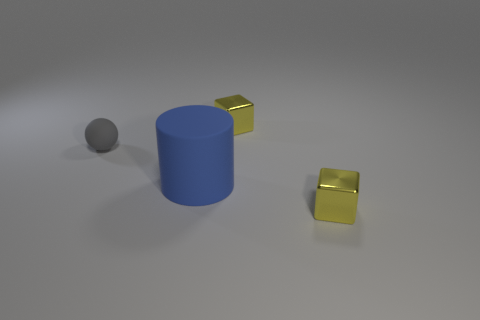What is the color of the tiny thing that is made of the same material as the big blue object?
Keep it short and to the point. Gray. What number of metal cubes are the same size as the gray matte thing?
Your answer should be compact. 2. Are there more matte objects than small objects?
Ensure brevity in your answer.  No. Does the small rubber object have the same shape as the big matte object?
Your response must be concise. No. Are there any other things that are the same shape as the large blue matte object?
Give a very brief answer. No. Do the shiny cube that is in front of the big matte cylinder and the metallic object that is behind the blue rubber thing have the same color?
Ensure brevity in your answer.  Yes. Is the number of small gray matte objects right of the tiny gray matte object less than the number of spheres that are behind the large matte cylinder?
Your answer should be compact. Yes. What is the shape of the big blue thing on the right side of the gray sphere?
Your answer should be very brief. Cylinder. What shape is the big blue object that is the same material as the gray ball?
Make the answer very short. Cylinder. Are there more gray balls behind the large blue rubber thing than big blue cylinders behind the tiny gray rubber sphere?
Make the answer very short. Yes. 